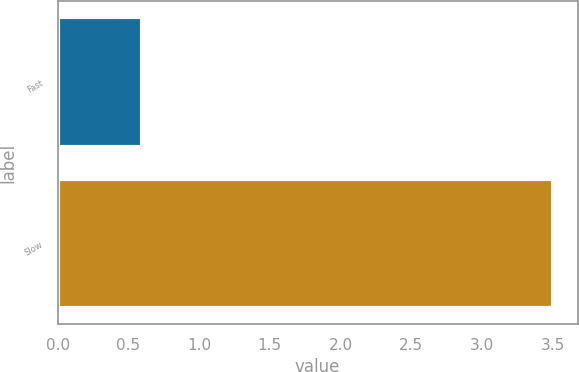Convert chart. <chart><loc_0><loc_0><loc_500><loc_500><bar_chart><fcel>Fast<fcel>Slow<nl><fcel>0.6<fcel>3.5<nl></chart> 